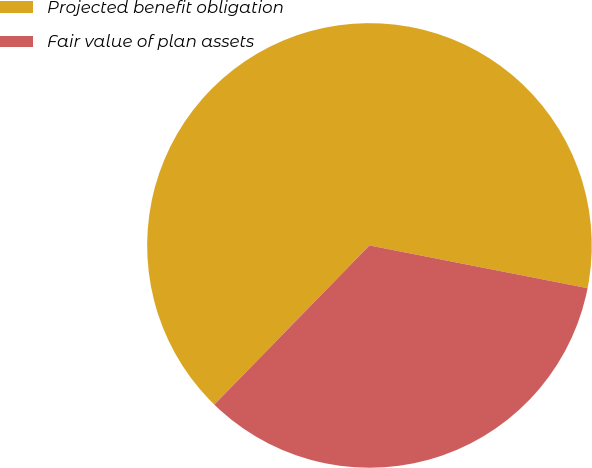Convert chart to OTSL. <chart><loc_0><loc_0><loc_500><loc_500><pie_chart><fcel>Projected benefit obligation<fcel>Fair value of plan assets<nl><fcel>65.78%<fcel>34.22%<nl></chart> 